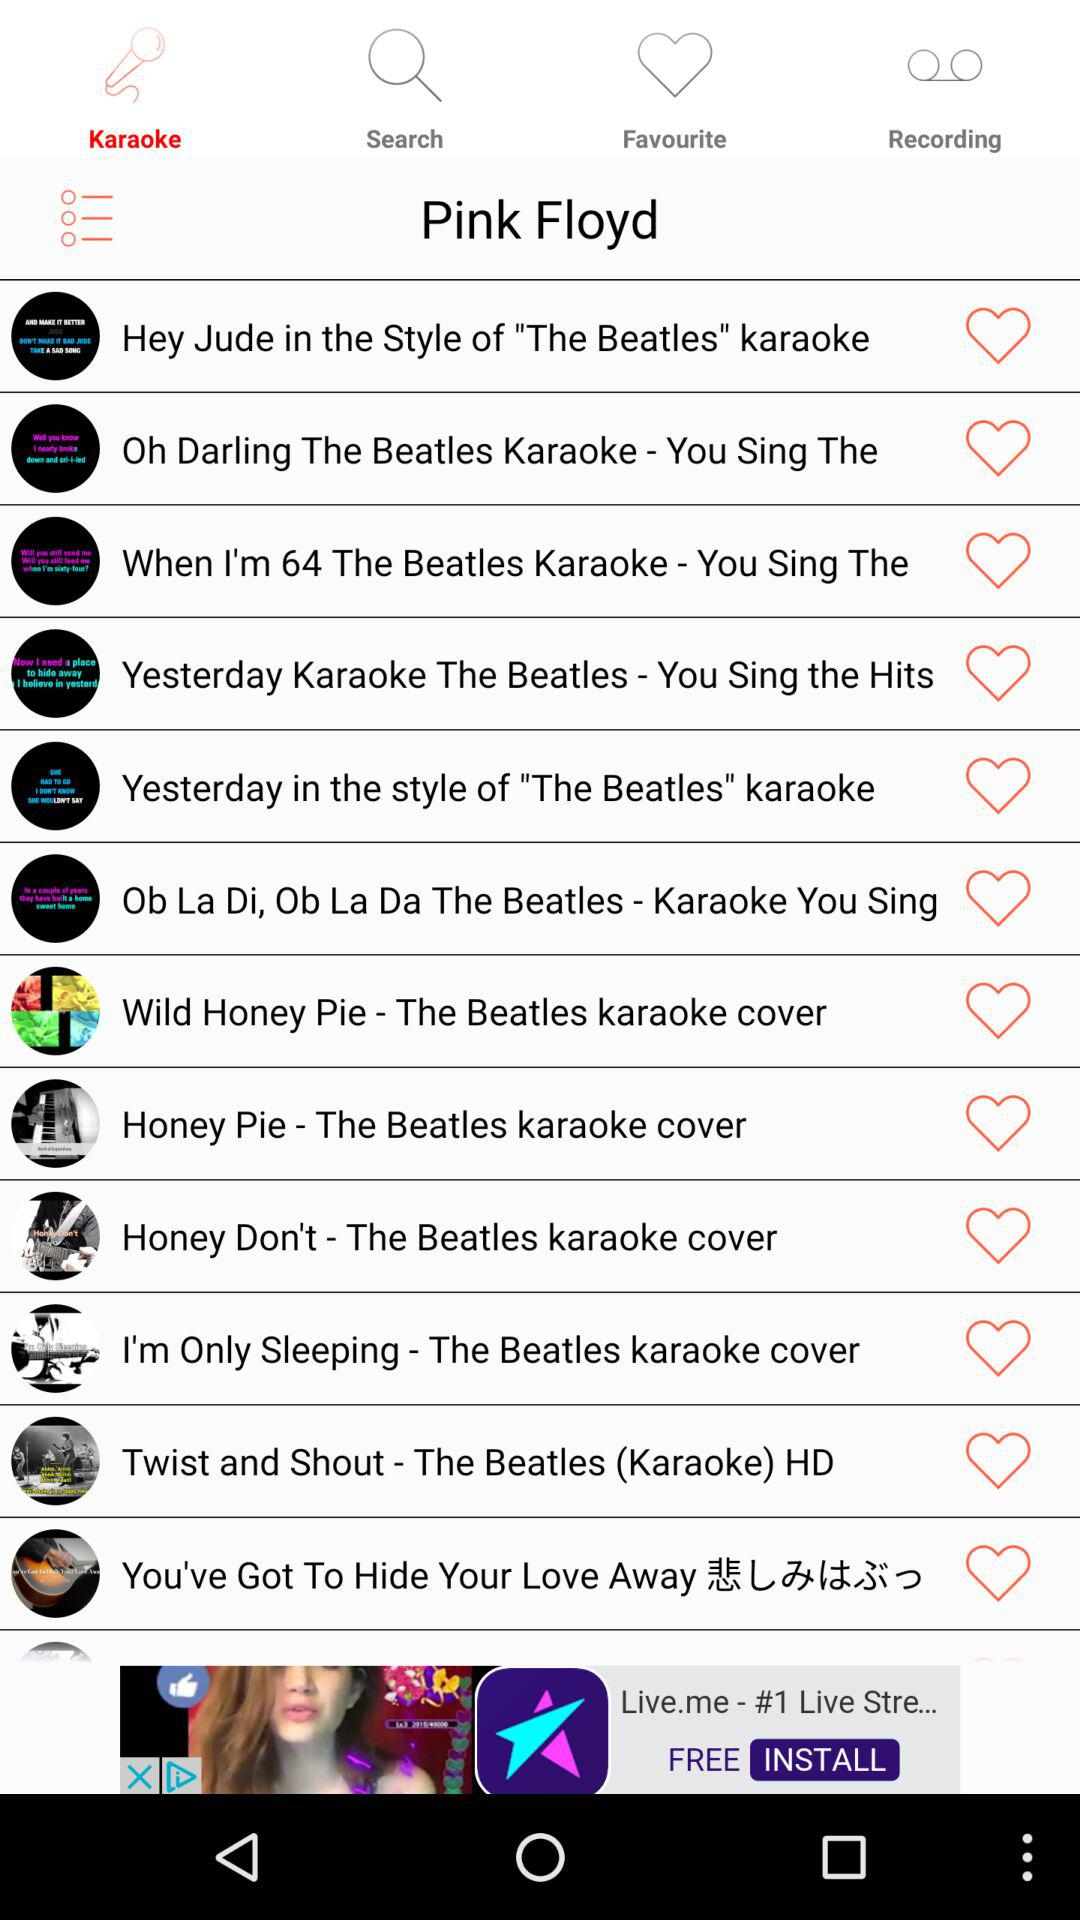Which tab is open? The open tab is "Karaoke". 